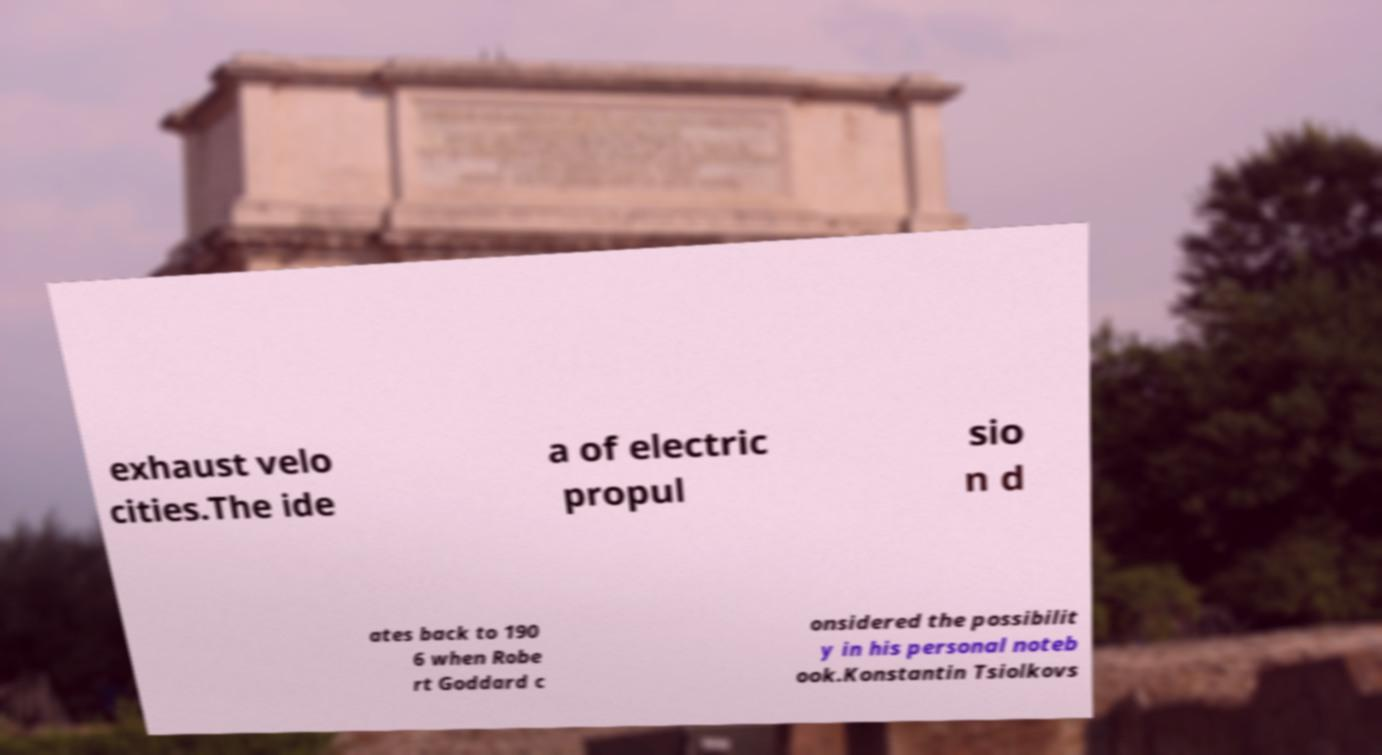Can you read and provide the text displayed in the image?This photo seems to have some interesting text. Can you extract and type it out for me? exhaust velo cities.The ide a of electric propul sio n d ates back to 190 6 when Robe rt Goddard c onsidered the possibilit y in his personal noteb ook.Konstantin Tsiolkovs 